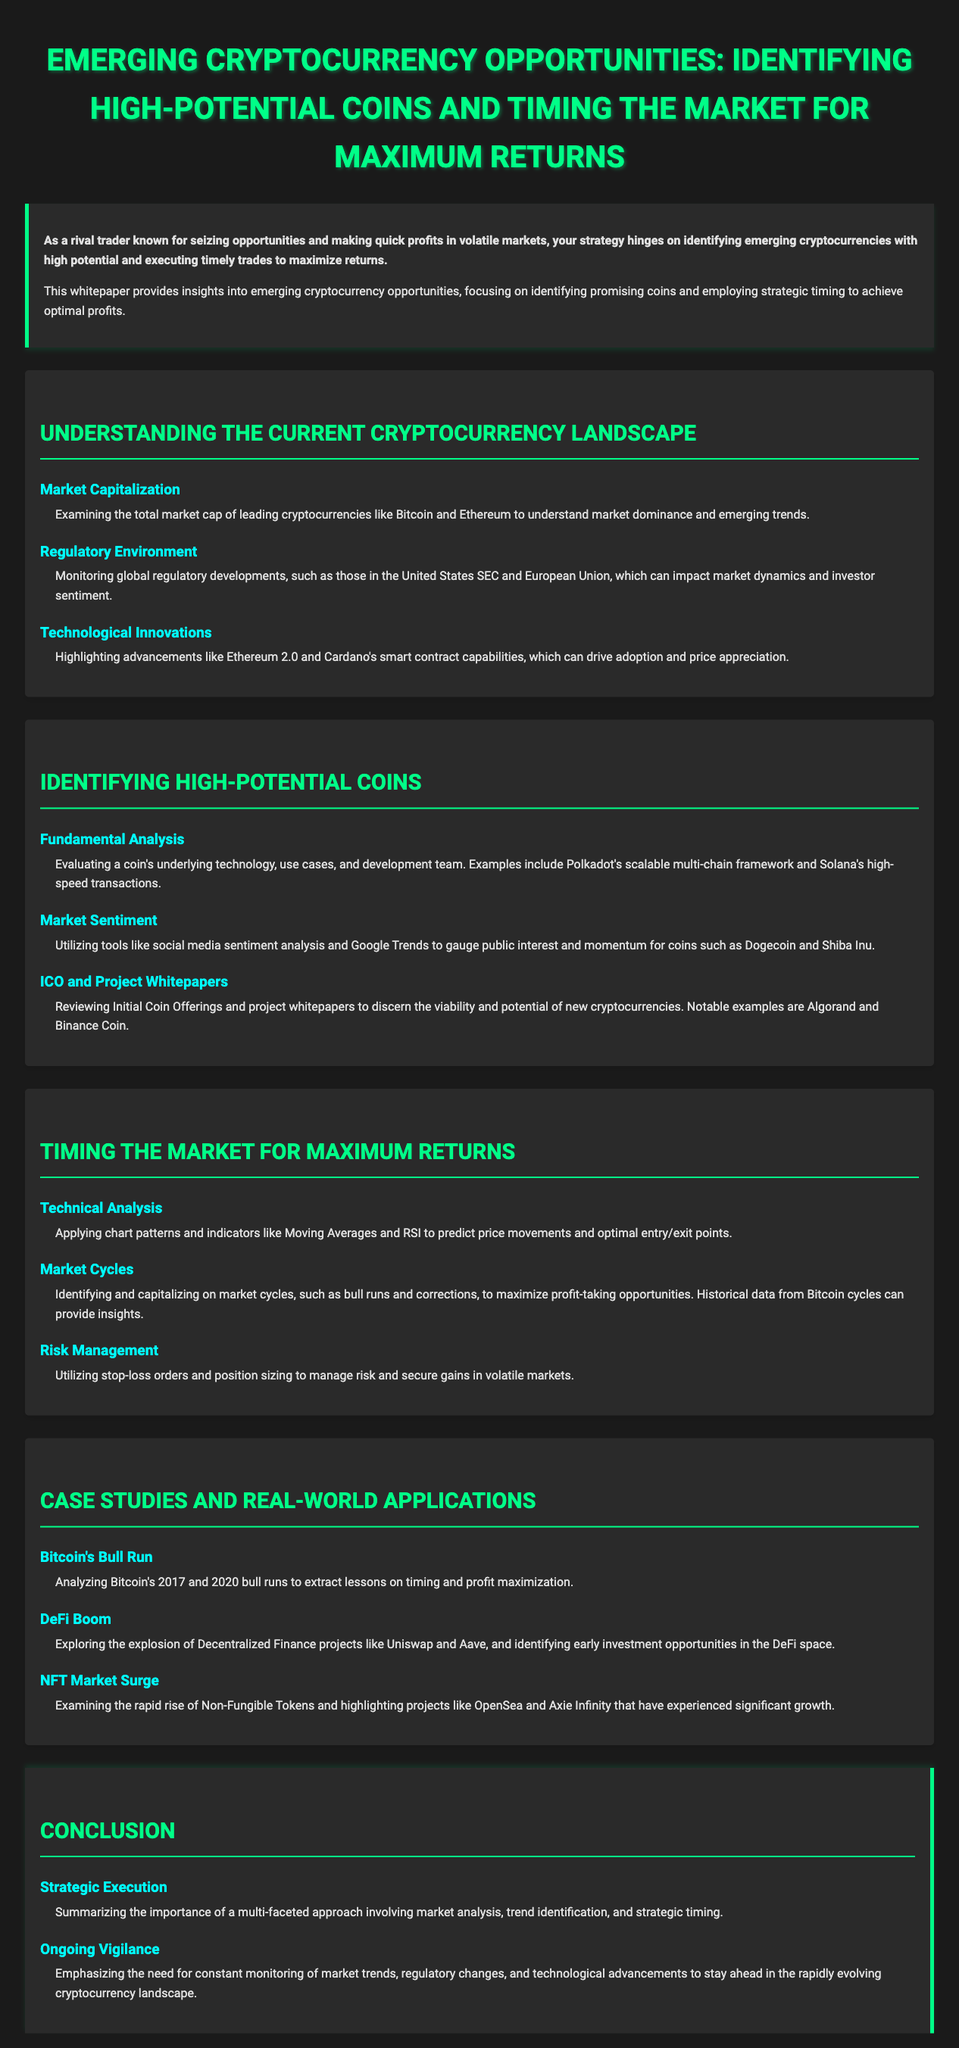What is the focus of this whitepaper? The focus of the whitepaper is identifying emerging cryptocurrencies with high potential and employing strategic timing to achieve optimal profits.
Answer: Identifying emerging cryptocurrencies with high potential and strategic timing What is one technological innovation highlighted in the document? The document highlights advancements like Ethereum 2.0 and Cardano's smart contract capabilities that can drive adoption and price appreciation.
Answer: Ethereum 2.0 Which cryptocurrency's bull runs are analyzed in the case studies? The case studies analyze Bitcoin's 2017 and 2020 bull runs to extract lessons on timing and profit maximization.
Answer: Bitcoin What analysis is utilized to gauge public interest in cryptocurrencies? The document mentions utilizing tools like social media sentiment analysis and Google Trends for gauging public interest.
Answer: Social media sentiment analysis What type of projects are explored in the DeFi Boom section? The DeFi Boom section explores Decentralized Finance projects like Uniswap and Aave.
Answer: Uniswap and Aave Which risk management strategy is mentioned for managing risk? The document mentions utilizing stop-loss orders and position sizing as risk management strategies.
Answer: Stop-loss orders and position sizing What is emphasized for staying ahead in the cryptocurrency landscape? The whitepaper emphasizes the need for constant monitoring of market trends, regulatory changes, and technological advancements.
Answer: Constant monitoring What does the term "ICO" refer to in the context of this document? In the context of this document, "ICO" refers to Initial Coin Offerings related to new cryptocurrencies.
Answer: Initial Coin Offerings 